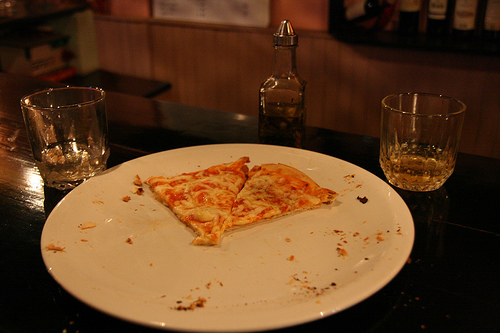What is the pizza on? The pizza is placed on a plain, white plate, which shows crumbs and oil traces, indicating a meal in progress. 